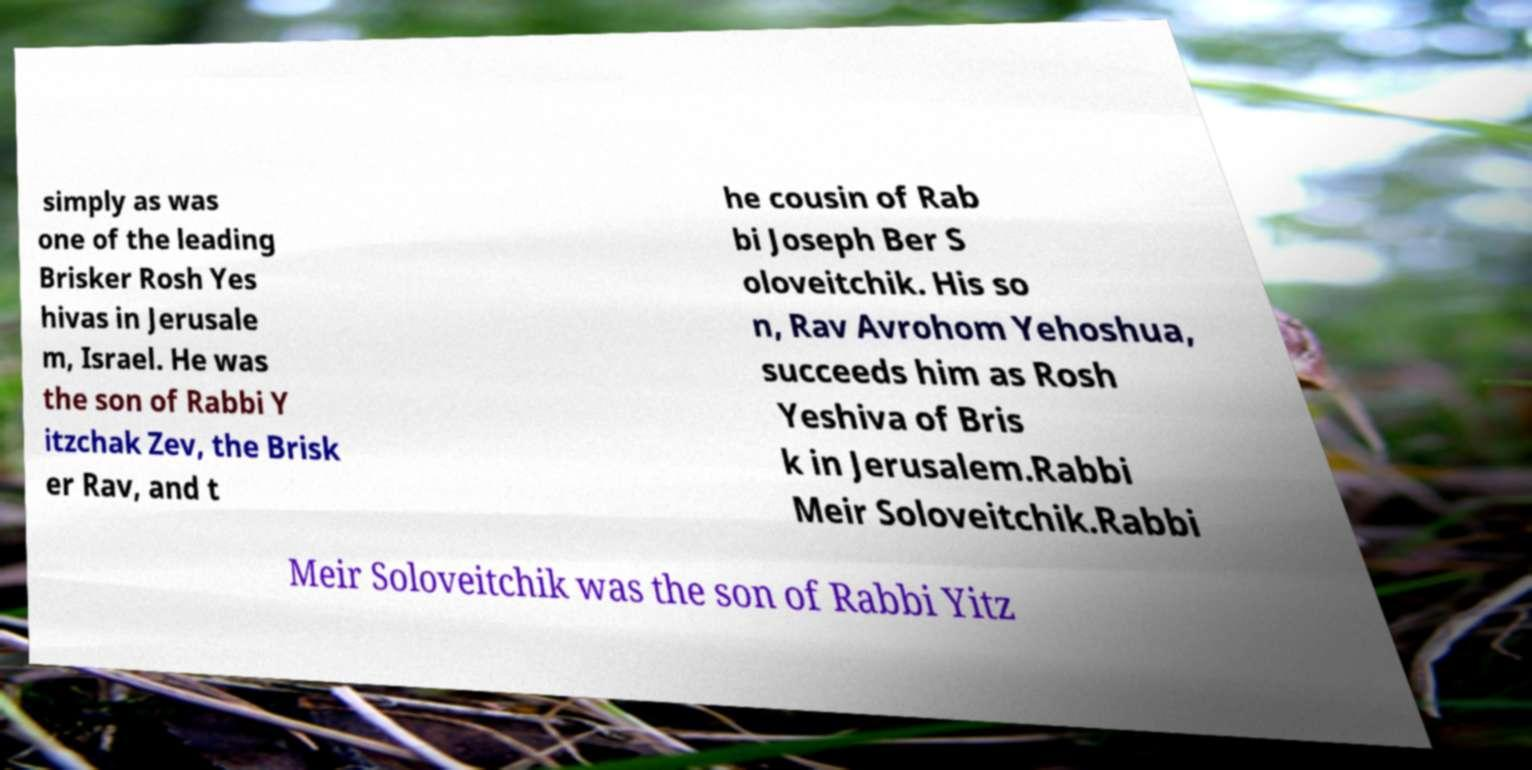What messages or text are displayed in this image? I need them in a readable, typed format. simply as was one of the leading Brisker Rosh Yes hivas in Jerusale m, Israel. He was the son of Rabbi Y itzchak Zev, the Brisk er Rav, and t he cousin of Rab bi Joseph Ber S oloveitchik. His so n, Rav Avrohom Yehoshua, succeeds him as Rosh Yeshiva of Bris k in Jerusalem.Rabbi Meir Soloveitchik.Rabbi Meir Soloveitchik was the son of Rabbi Yitz 